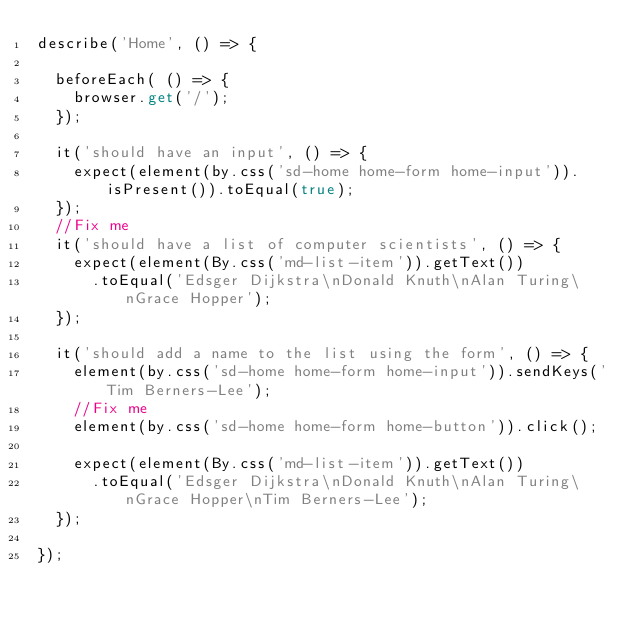<code> <loc_0><loc_0><loc_500><loc_500><_TypeScript_>describe('Home', () => {

  beforeEach( () => {
    browser.get('/');
  });

  it('should have an input', () => {
    expect(element(by.css('sd-home home-form home-input')).isPresent()).toEqual(true);
  });
  //Fix me
  it('should have a list of computer scientists', () => {
    expect(element(By.css('md-list-item')).getText())
      .toEqual('Edsger Dijkstra\nDonald Knuth\nAlan Turing\nGrace Hopper');
  });

  it('should add a name to the list using the form', () => {
    element(by.css('sd-home home-form home-input')).sendKeys('Tim Berners-Lee');
    //Fix me
    element(by.css('sd-home home-form home-button')).click();

    expect(element(By.css('md-list-item')).getText())
      .toEqual('Edsger Dijkstra\nDonald Knuth\nAlan Turing\nGrace Hopper\nTim Berners-Lee');
  });

});
</code> 